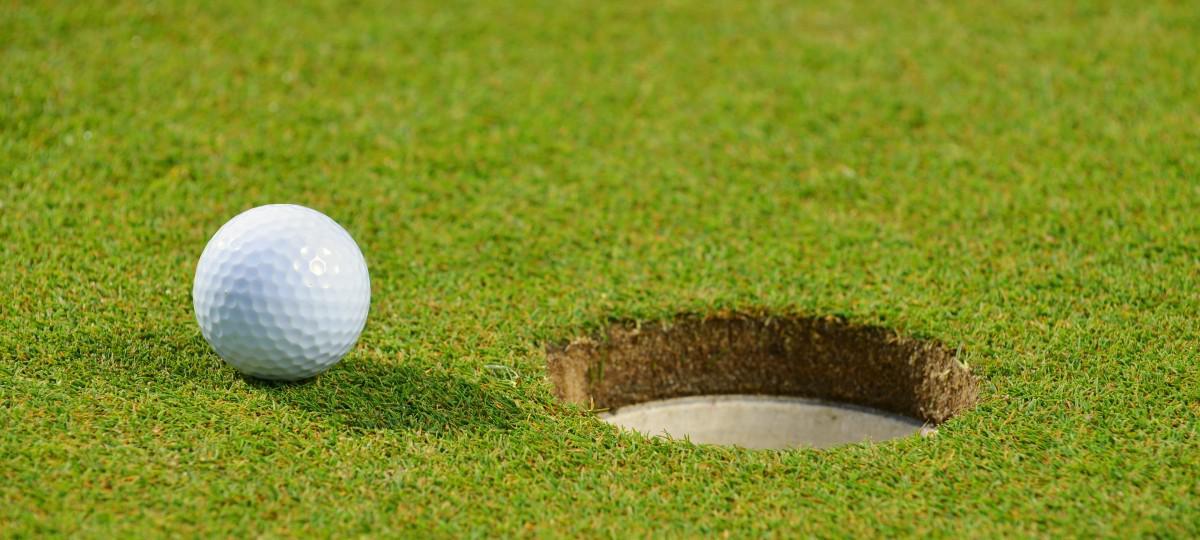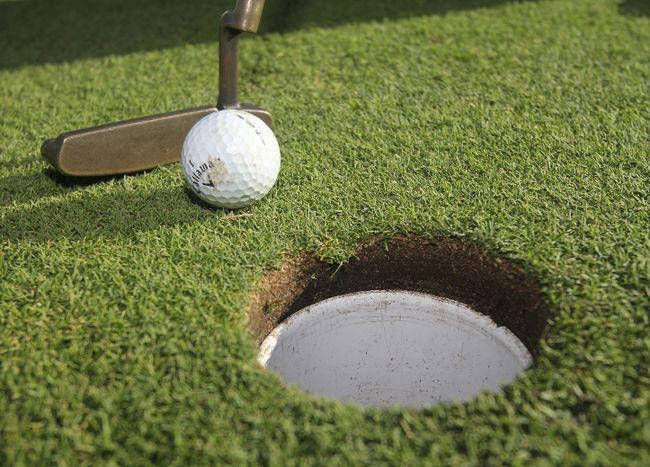The first image is the image on the left, the second image is the image on the right. Assess this claim about the two images: "An image shows a golf club behind a ball that is not on a tee.". Correct or not? Answer yes or no. Yes. The first image is the image on the left, the second image is the image on the right. For the images shown, is this caption "The ball is near the hole." true? Answer yes or no. Yes. 